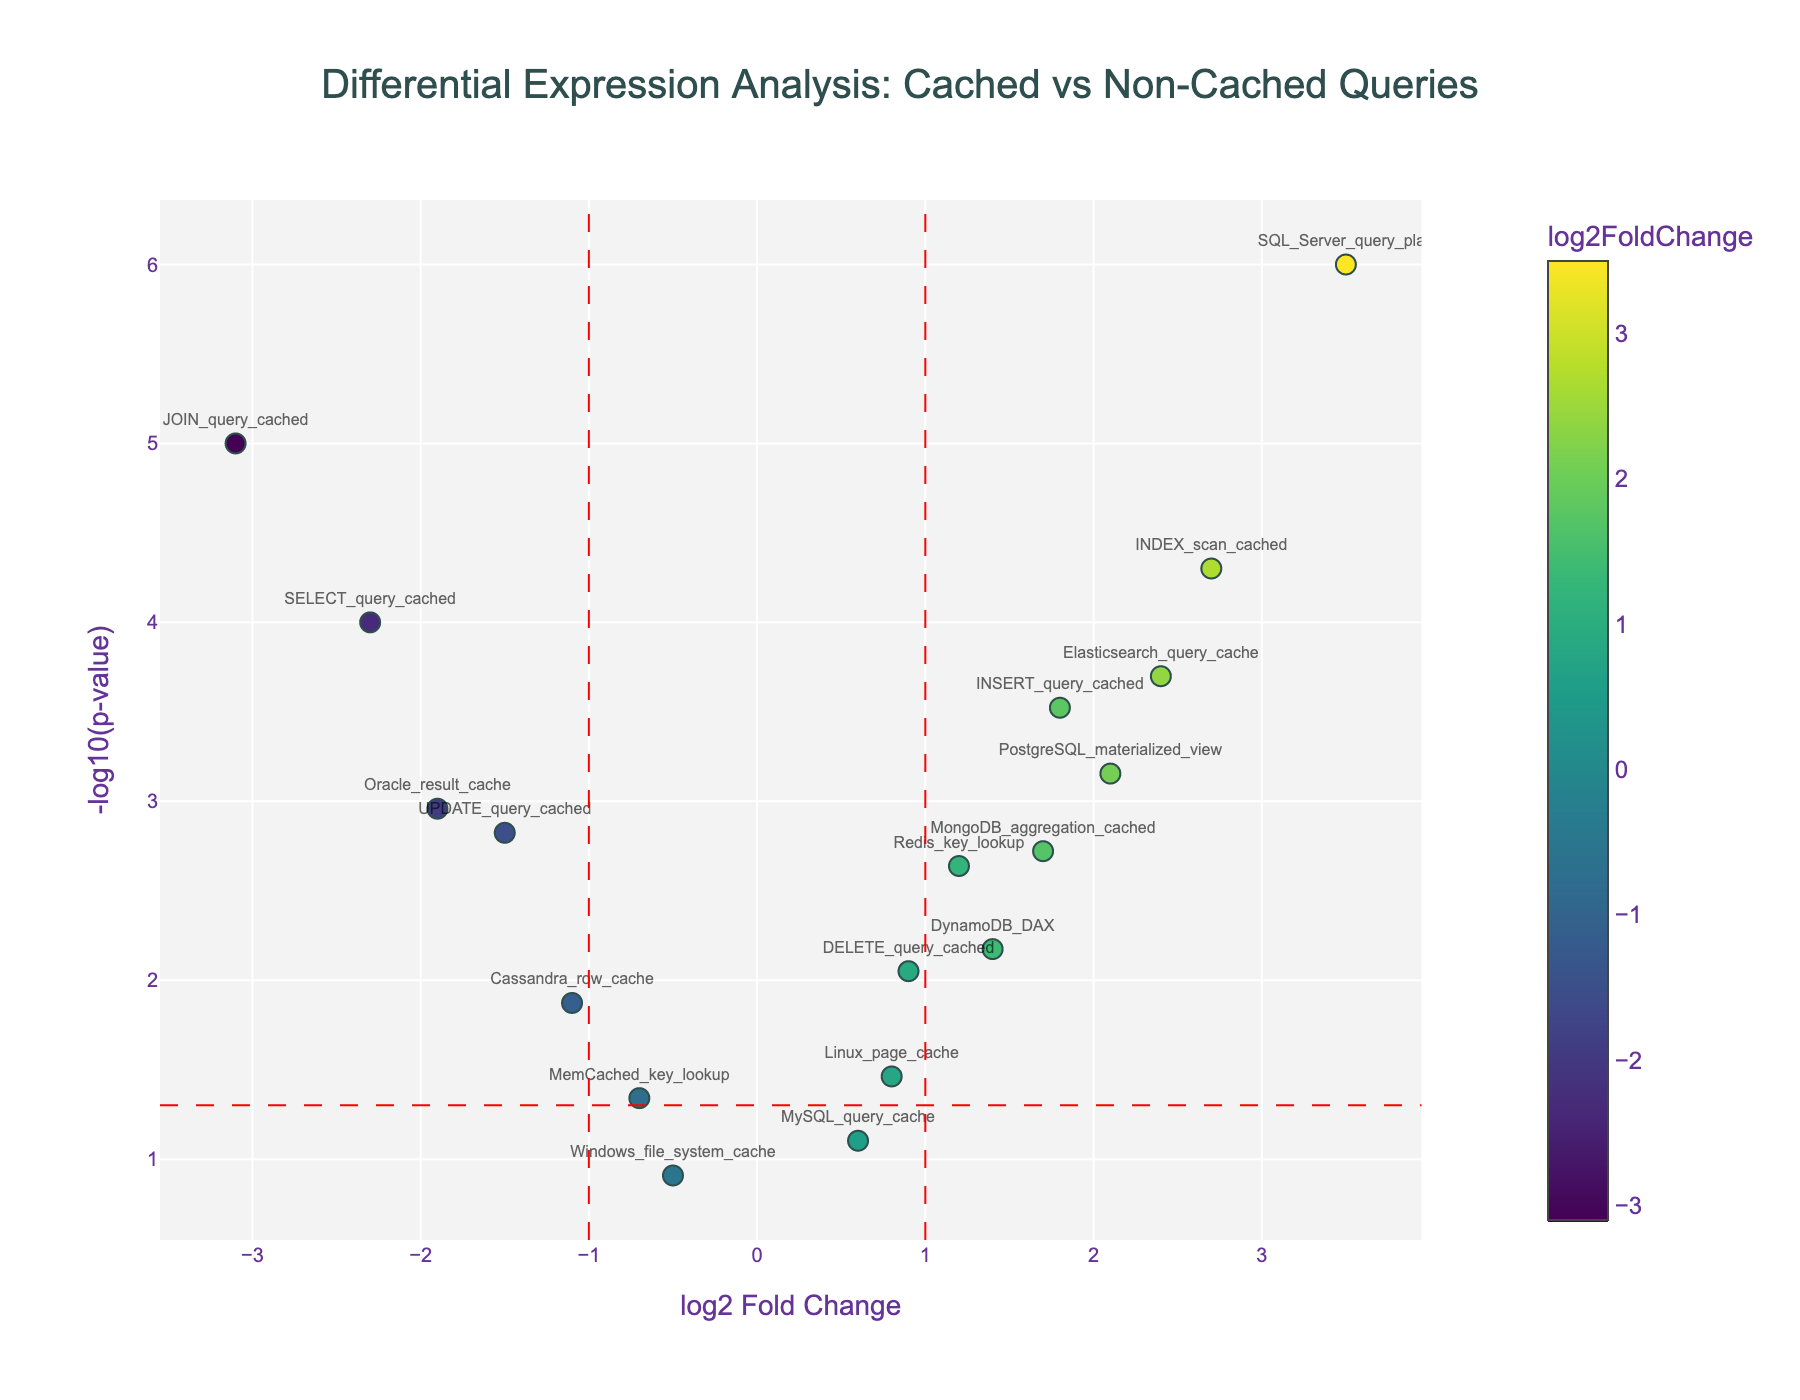How many data points are labeled in the plot? The plot shows markers with labels for each data point. Counting the number of labeled data points directly in the plot.
Answer: 18 Which query has the highest log2 Fold Change value? Look at the x-axis, find the data point with the highest value and refer to the label.
Answer: SQL_Server_query_plan What is the threshold set for significance in terms of p-value? Horizontal red line marks the threshold; check its position on the y-axis.
Answer: 0.05 Which data points lie between -1 and 1 log2 Fold Change but are still significant? Identify data points between -1 and 1 on the x-axis that are above the red horizontal line (significance threshold).
Answer: DELETE_query_cached, Redis_key_lookup, Cassandra_row_cache, DynamoDB_DAX, Linux_page_cache Which of these queries showed a log2 Fold Change less than 0 and a highly significant p-value? Look for data points on the left side of zero on the x-axis that are high above the significance line.
Answer: SELECT_query_cached, UPDATE_query_cached, JOIN_query_cached, Oracle_result_cache Among the cached queries, which had the lowest p-value? What was its log2 Fold Change? Find the cached queries, then look for the one with the highest y-axis value. Note its x-axis value too.
Answer: JOIN_query_cached; -3.1 Identify the query type with a log2 Fold Change of approximately 0.6 and its p-value. Locate the point on the x-axis near 0.6, then check its y-axis position and label.
Answer: MySQL_query_cache; 0.0789 Which query type has the least log2 Fold Change but is not considered significant based on p-value? Find the least log2 Fold Change value on the x-axis that is below the significance line.
Answer: Windows_file_system_cache Compare the significance levels of Elasticsearch_query_cache and MongoDB_aggregation_cached. Which one is more significant? Look at the y-axis positions for both data points. The higher value represents more significant.
Answer: Elasticsearch_query_cache What do vertical red dashed lines represent in the plot? Vertical dashed lines indicate a specific x-axis value. These lines usually signify thresholds for log2 Fold Change.
Answer: Thresholds at -1 and 1 log2 Fold Change 